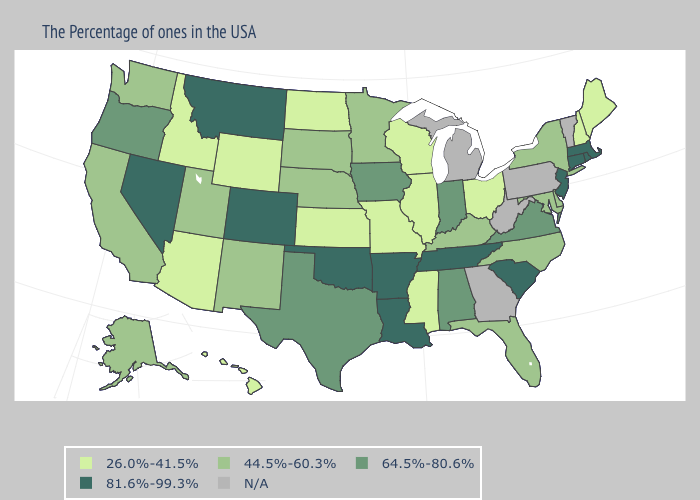Name the states that have a value in the range 64.5%-80.6%?
Quick response, please. Virginia, Indiana, Alabama, Iowa, Texas, Oregon. Name the states that have a value in the range N/A?
Answer briefly. Vermont, Pennsylvania, West Virginia, Georgia, Michigan. Name the states that have a value in the range N/A?
Answer briefly. Vermont, Pennsylvania, West Virginia, Georgia, Michigan. Which states have the lowest value in the MidWest?
Give a very brief answer. Ohio, Wisconsin, Illinois, Missouri, Kansas, North Dakota. Is the legend a continuous bar?
Be succinct. No. Name the states that have a value in the range 64.5%-80.6%?
Answer briefly. Virginia, Indiana, Alabama, Iowa, Texas, Oregon. Does the first symbol in the legend represent the smallest category?
Write a very short answer. Yes. What is the value of South Carolina?
Write a very short answer. 81.6%-99.3%. Which states have the lowest value in the South?
Write a very short answer. Mississippi. What is the value of Pennsylvania?
Keep it brief. N/A. What is the value of Montana?
Concise answer only. 81.6%-99.3%. Does the first symbol in the legend represent the smallest category?
Keep it brief. Yes. 